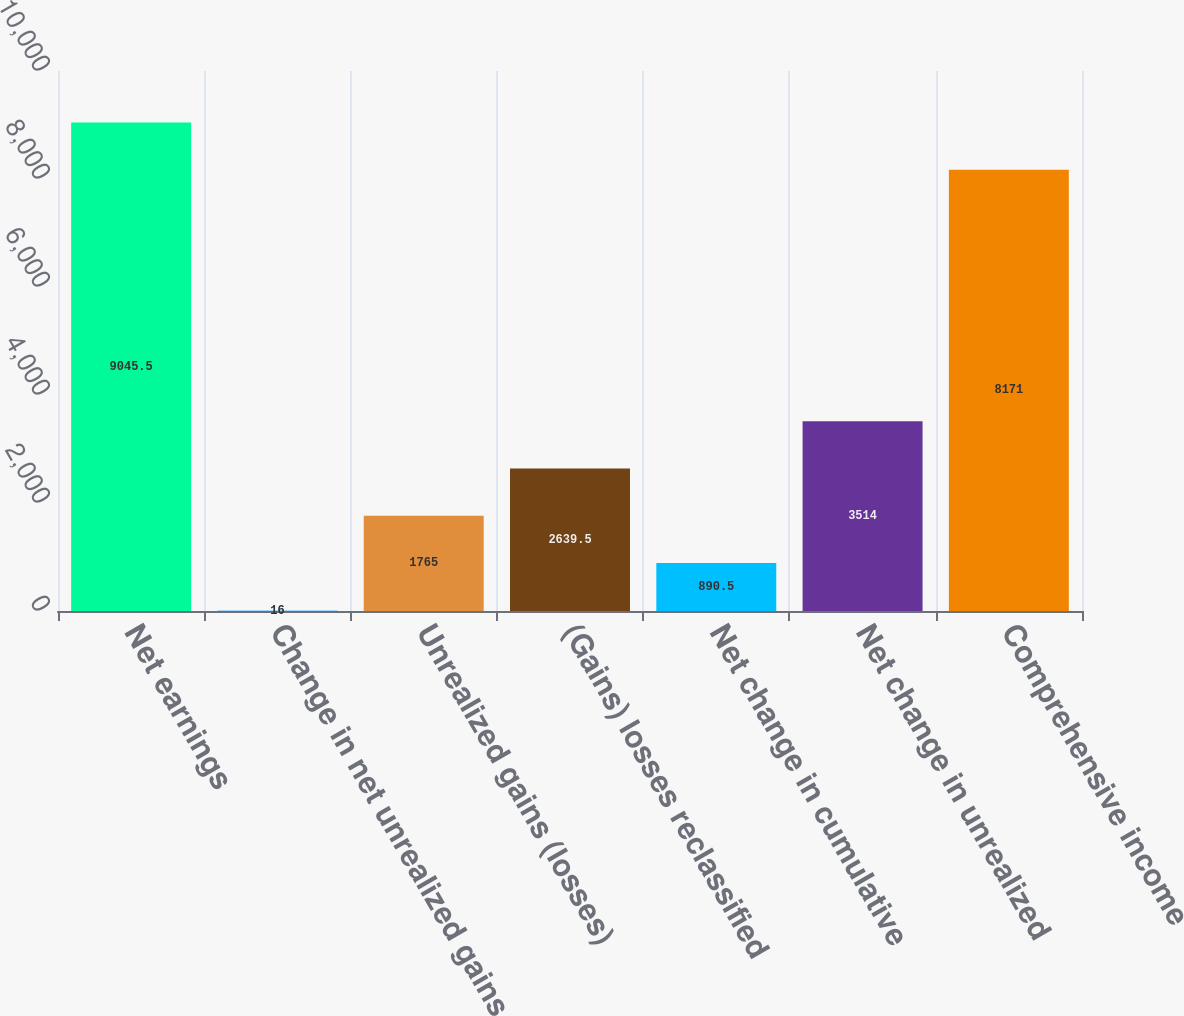<chart> <loc_0><loc_0><loc_500><loc_500><bar_chart><fcel>Net earnings<fcel>Change in net unrealized gains<fcel>Unrealized gains (losses)<fcel>(Gains) losses reclassified<fcel>Net change in cumulative<fcel>Net change in unrealized<fcel>Comprehensive income<nl><fcel>9045.5<fcel>16<fcel>1765<fcel>2639.5<fcel>890.5<fcel>3514<fcel>8171<nl></chart> 